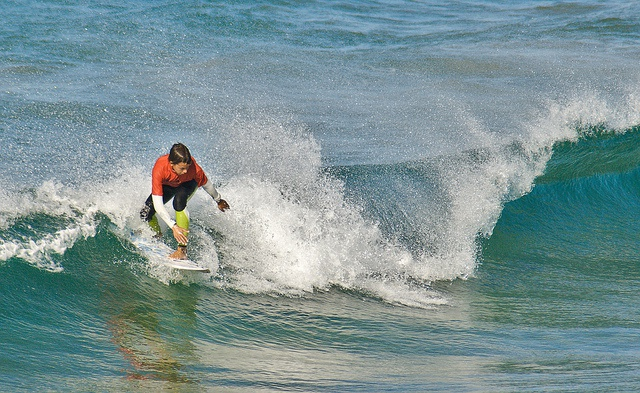Describe the objects in this image and their specific colors. I can see people in teal, black, ivory, maroon, and red tones and surfboard in teal, lightgray, darkgray, and lightblue tones in this image. 